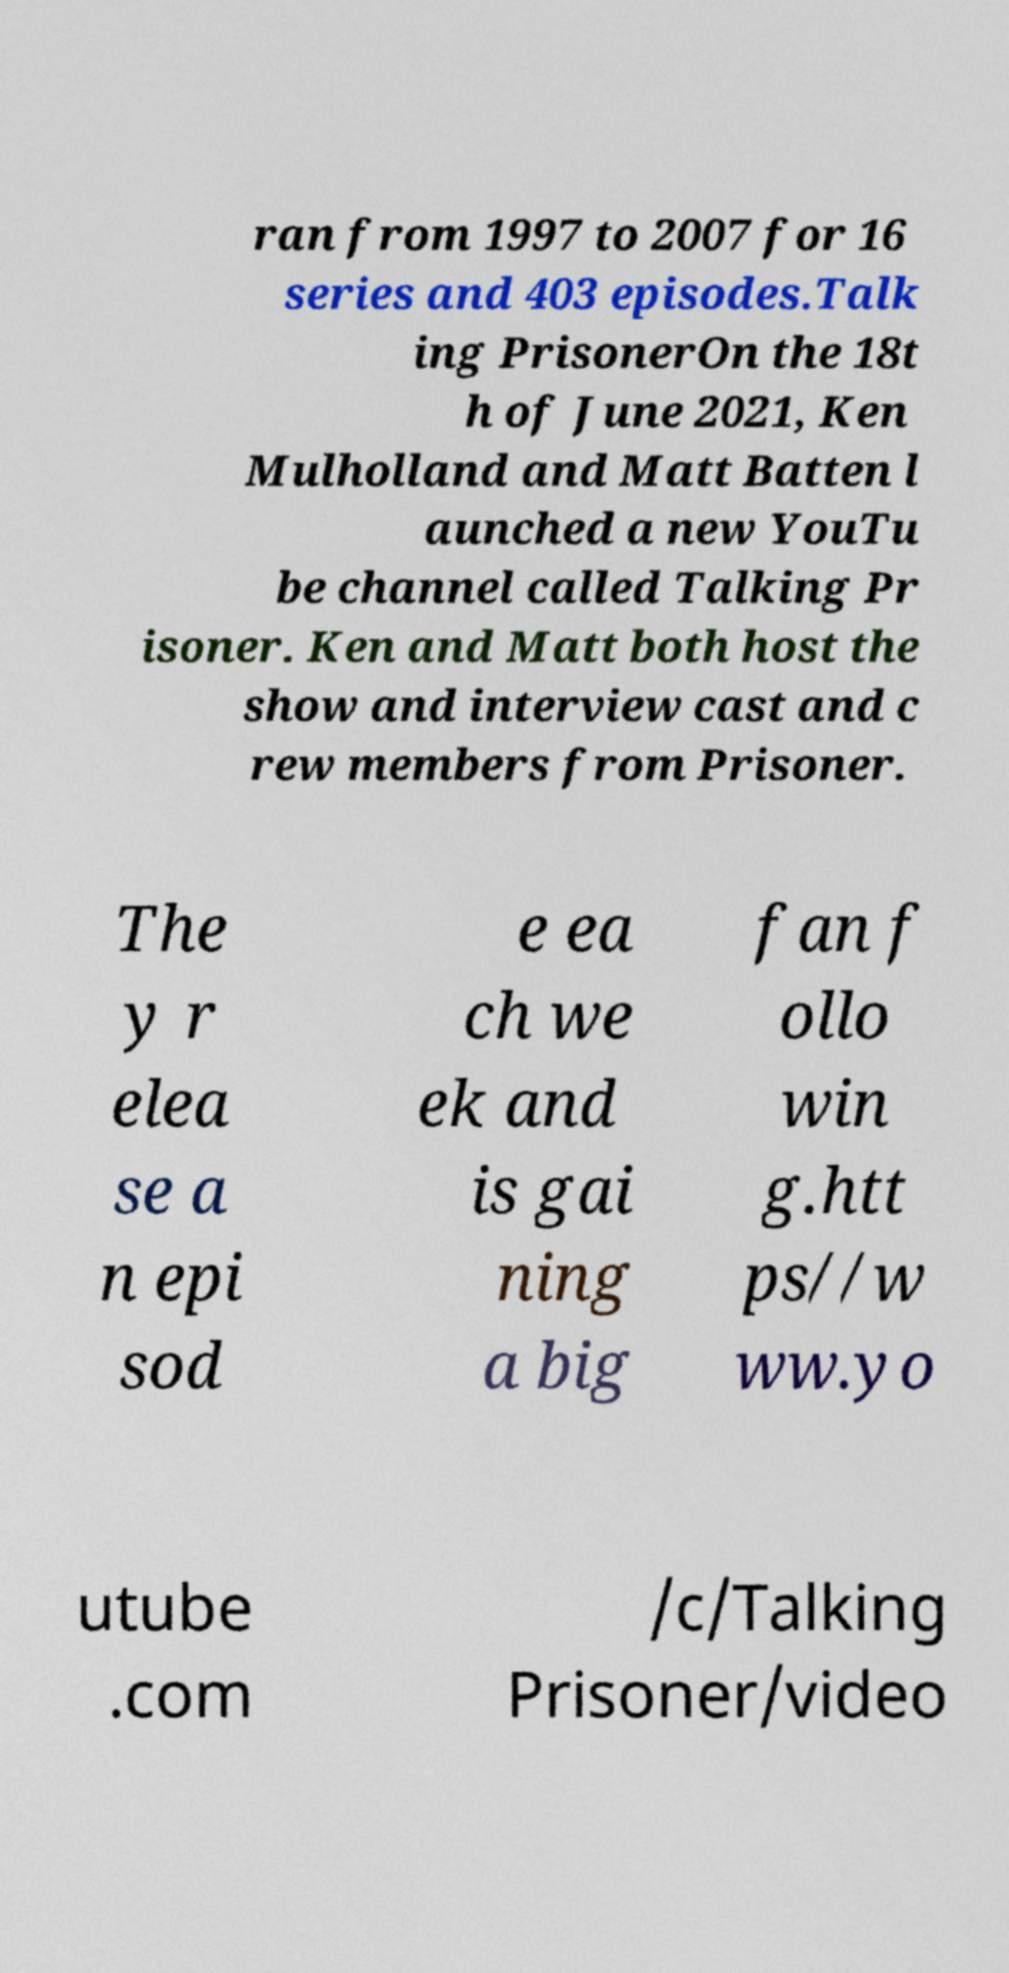Can you read and provide the text displayed in the image?This photo seems to have some interesting text. Can you extract and type it out for me? ran from 1997 to 2007 for 16 series and 403 episodes.Talk ing PrisonerOn the 18t h of June 2021, Ken Mulholland and Matt Batten l aunched a new YouTu be channel called Talking Pr isoner. Ken and Matt both host the show and interview cast and c rew members from Prisoner. The y r elea se a n epi sod e ea ch we ek and is gai ning a big fan f ollo win g.htt ps//w ww.yo utube .com /c/Talking Prisoner/video 